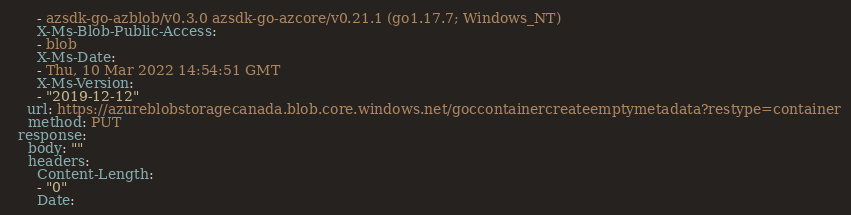Convert code to text. <code><loc_0><loc_0><loc_500><loc_500><_YAML_>      - azsdk-go-azblob/v0.3.0 azsdk-go-azcore/v0.21.1 (go1.17.7; Windows_NT)
      X-Ms-Blob-Public-Access:
      - blob
      X-Ms-Date:
      - Thu, 10 Mar 2022 14:54:51 GMT
      X-Ms-Version:
      - "2019-12-12"
    url: https://azureblobstoragecanada.blob.core.windows.net/goccontainercreateemptymetadata?restype=container
    method: PUT
  response:
    body: ""
    headers:
      Content-Length:
      - "0"
      Date:</code> 